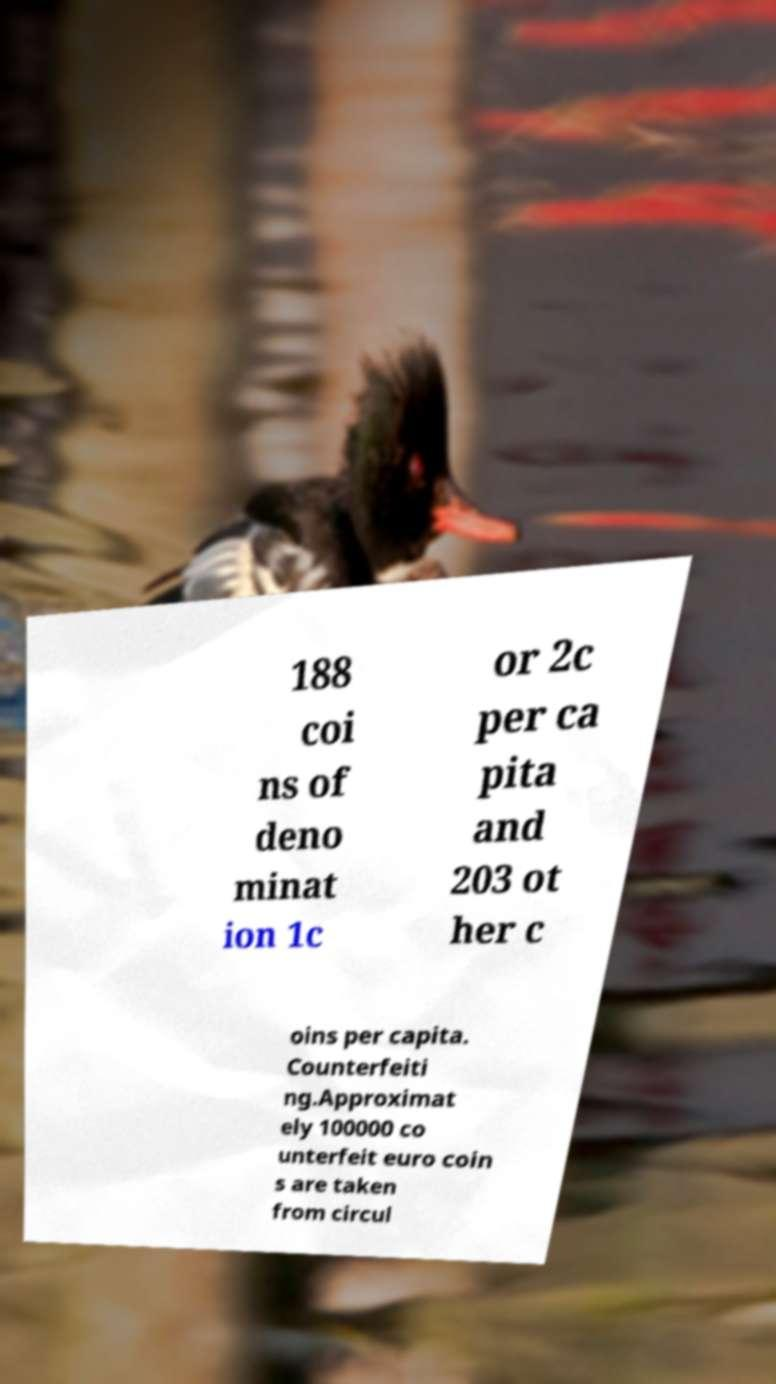There's text embedded in this image that I need extracted. Can you transcribe it verbatim? 188 coi ns of deno minat ion 1c or 2c per ca pita and 203 ot her c oins per capita. Counterfeiti ng.Approximat ely 100000 co unterfeit euro coin s are taken from circul 